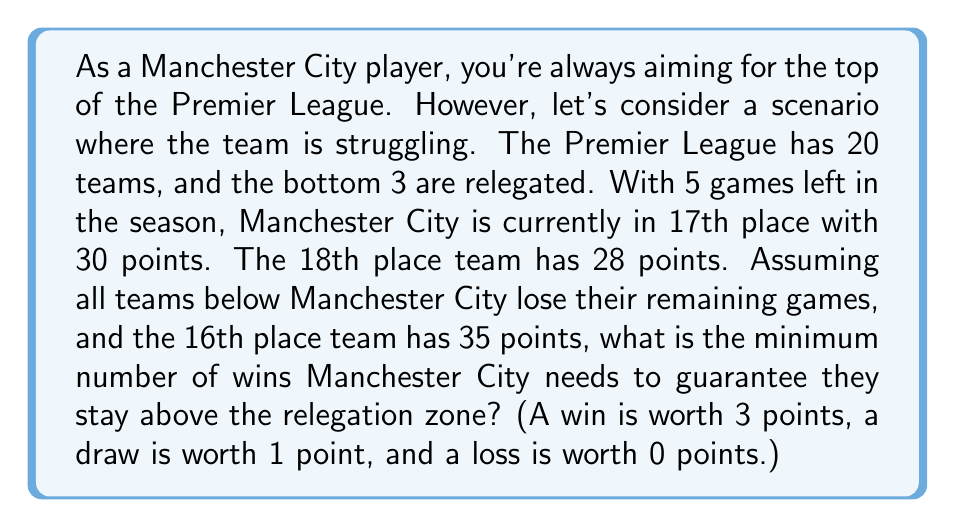Can you solve this math problem? Let's approach this step-by-step:

1) First, we need to calculate how many points the 18th place team could potentially get:
   $28 + (5 \times 3) = 28 + 15 = 43$ points

2) To stay above relegation, Manchester City needs to have more points than this. So we need to find $x$ such that:
   $30 + 3x > 43$, where $x$ is the number of wins needed.

3) Solving this inequality:
   $30 + 3x > 43$
   $3x > 13$
   $x > \frac{13}{3} \approx 4.33$

4) Since $x$ must be a whole number (you can't win a fraction of a game), we need to round up to the next integer.

5) Therefore, Manchester City needs a minimum of 5 wins to guarantee staying above the relegation zone.

6) We can verify this:
   With 5 wins: $30 + (5 \times 3) = 45$ points
   This is indeed greater than 43 points.

7) With 4 wins: $30 + (4 \times 3) = 42$ points
   This would not be enough to guarantee staying above relegation.
Answer: Manchester City needs a minimum of 5 wins to guarantee staying above the relegation zone. 